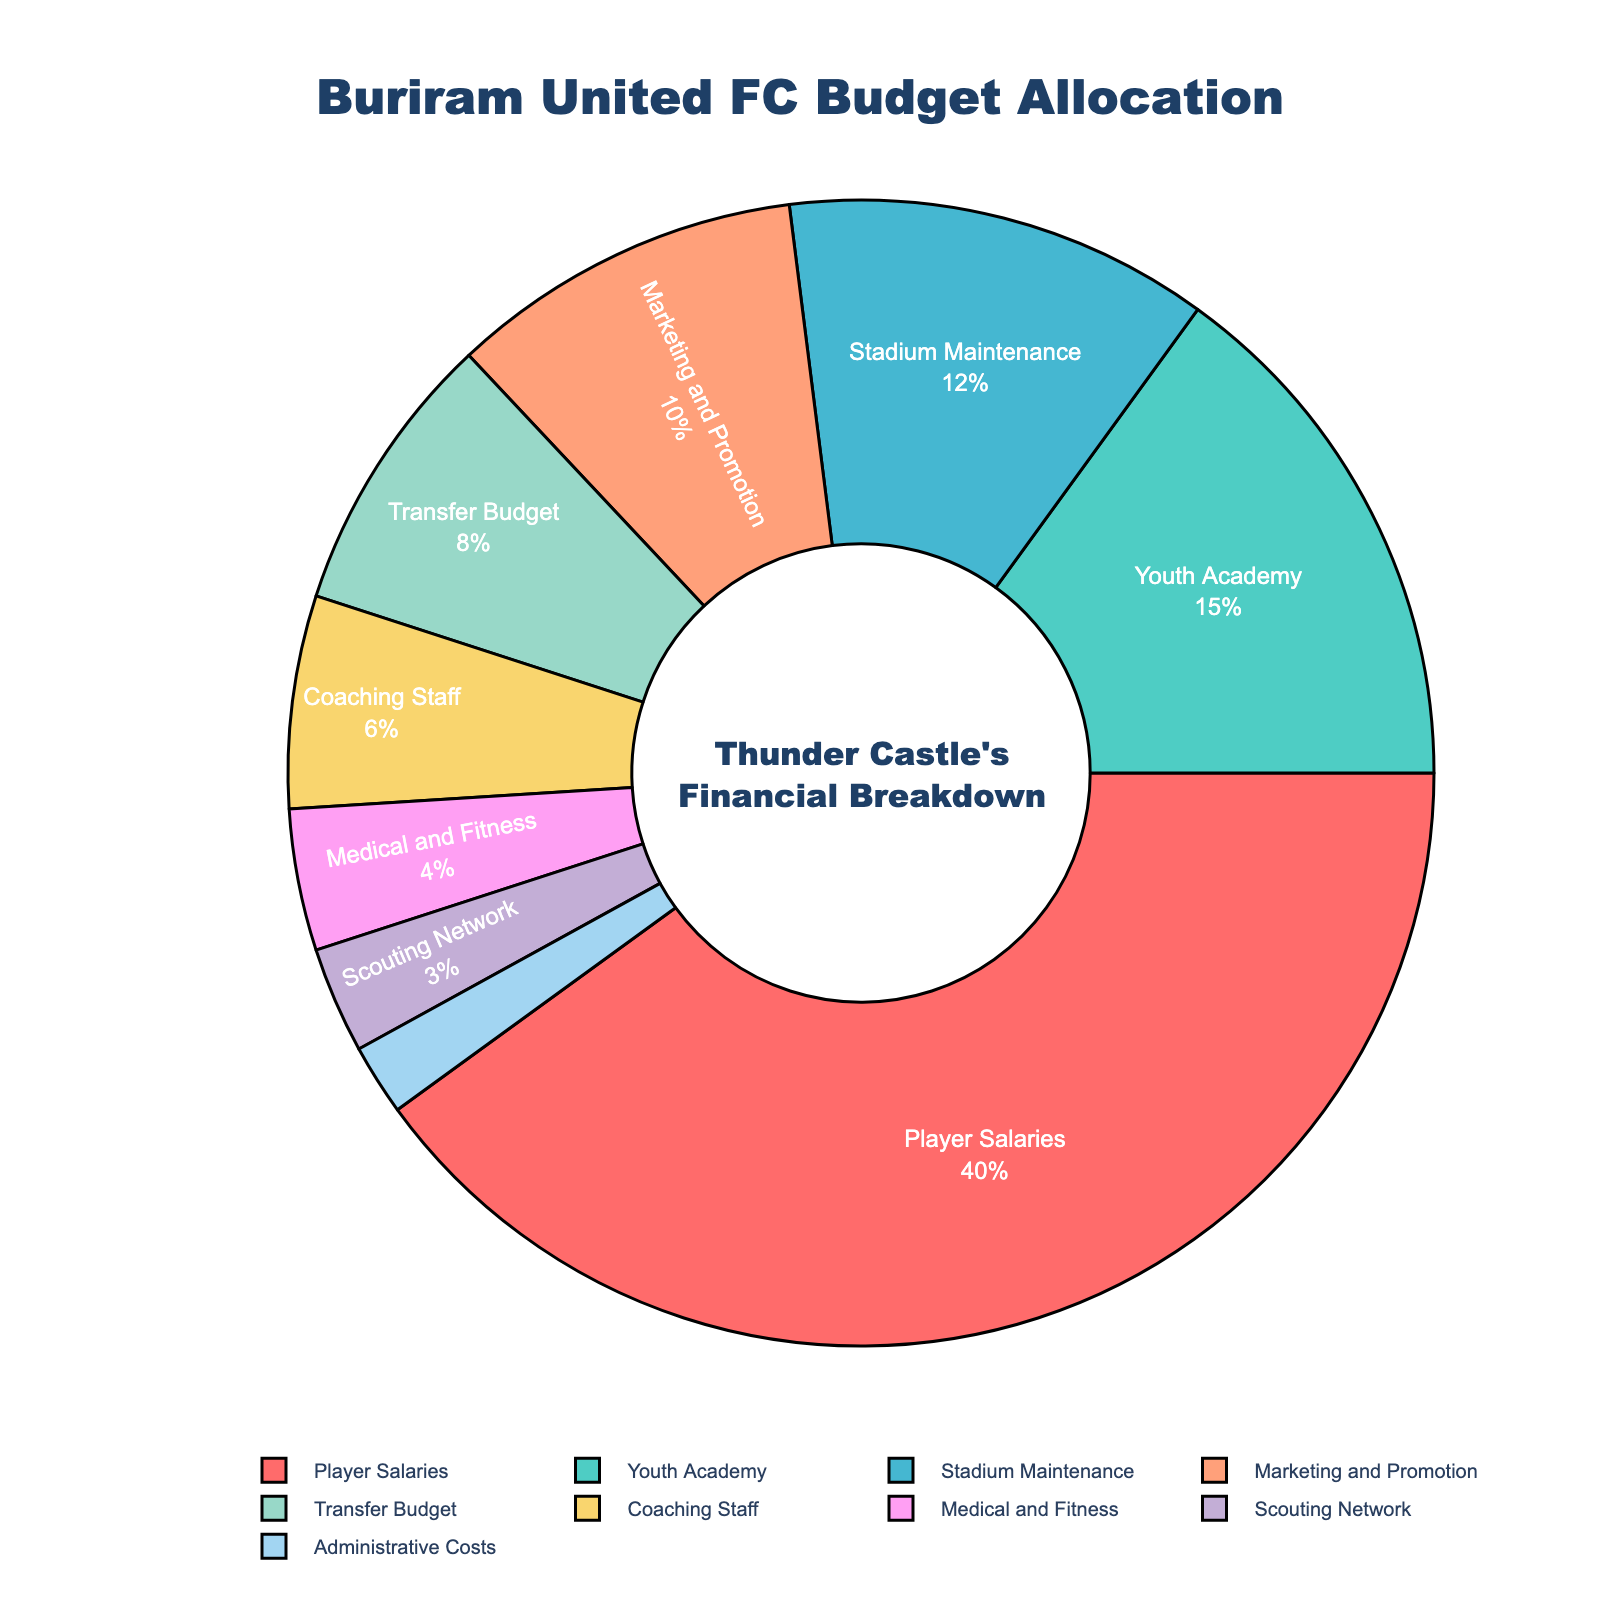What department gets the largest portion of the budget? The pie chart shows that Player Salaries gets the largest portion at 40% of the total budget.
Answer: Player Salaries Which area receives a smaller budget allocation, Youth Academy or Marketing and Promotion? Youth Academy is allocated 15% of the budget, while Marketing and Promotion gets 10%. Therefore, Marketing and Promotion receives a smaller budget allocation.
Answer: Marketing and Promotion How much more budget is allocated to Stadium Maintenance compared to Medical and Fitness? Stadium Maintenance is allocated 12% of the budget, while Medical and Fitness gets 4%. The difference is 12% - 4% = 8%.
Answer: 8% Calculate the total percentage of the budget allocated to Player Salaries and Transfer Budget combined. Player Salaries get 40%, and Transfer Budget gets 8%. Their combined allocation is 40% + 8% = 48%.
Answer: 48% What is the difference in budget allocation between Coaching Staff and Scouting Network? Coaching Staff receives 6% of the budget, and Scouting Network receives 3%. The difference is 6% - 3% = 3%.
Answer: 3% How many departments have a budget allocation of less than 10%? Marketing and Promotion (10%), Transfer Budget (8%), Coaching Staff (6%), Medical and Fitness (4%), Scouting Network (3%), and Administrative Costs (2%) are all below 10%. There are 6 such departments.
Answer: 6 Comparing the allocation percentages for Youth Academy and Stadium Maintenance, which one is visually represented with a larger slice and by how much? Youth Academy is allocated 15%, and Stadium Maintenance is allocated 12%. The difference is 15% - 12% = 3%. Youth Academy has a larger allocation by 3%.
Answer: Youth Academy, 3% If the total budget is $10,000,000, how much money is allocated to Administrative Costs? Administrative Costs are allocated 2% of the budget. Therefore, 2% of $10,000,000 is 0.02 * $10,000,000 = $200,000.
Answer: $200,000 What percentage of the budget is allocated to areas other than Player Salaries and Youth Academy? Player Salaries get 40% and Youth Academy gets 15%. The remaining percentage is 100% - 40% - 15% = 45%.
Answer: 45% 